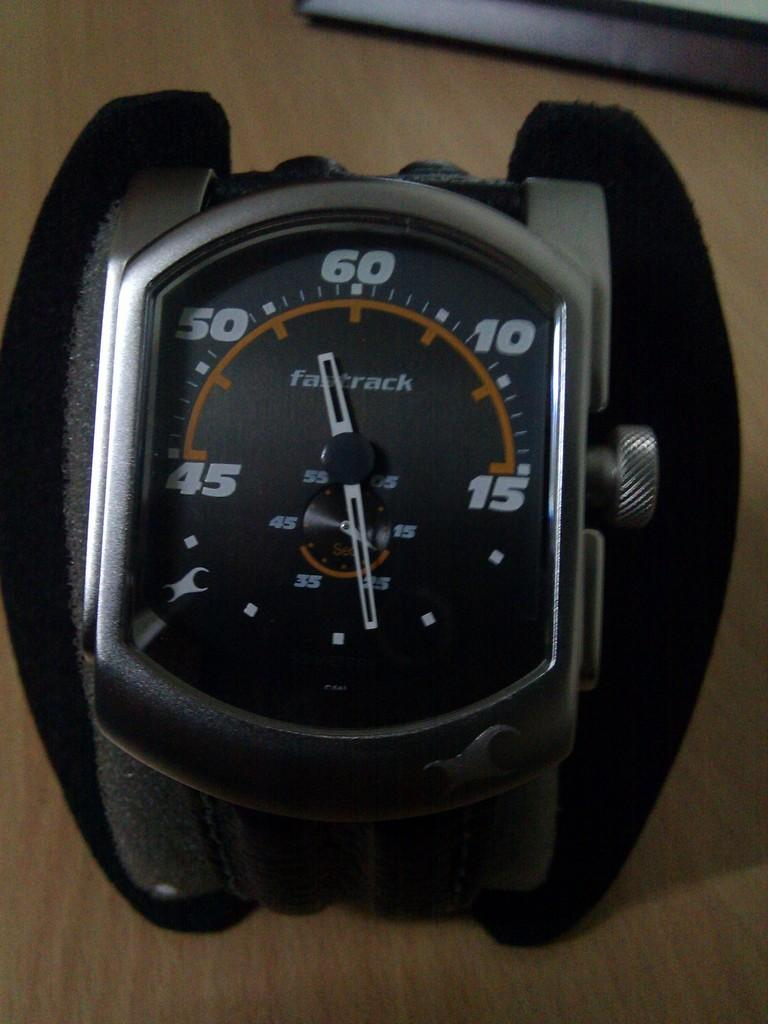<image>
Give a short and clear explanation of the subsequent image. Face of a watch which says the word Fastrack on it. 